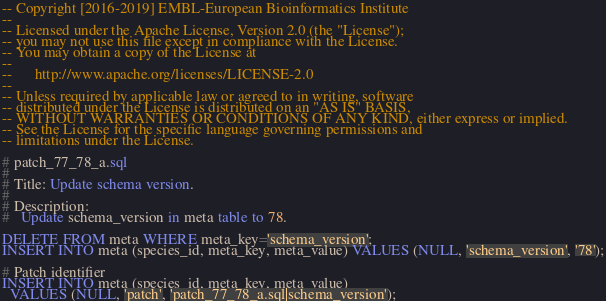Convert code to text. <code><loc_0><loc_0><loc_500><loc_500><_SQL_>-- Copyright [2016-2019] EMBL-European Bioinformatics Institute
-- 
-- Licensed under the Apache License, Version 2.0 (the "License");
-- you may not use this file except in compliance with the License.
-- You may obtain a copy of the License at
-- 
--      http://www.apache.org/licenses/LICENSE-2.0
-- 
-- Unless required by applicable law or agreed to in writing, software
-- distributed under the License is distributed on an "AS IS" BASIS,
-- WITHOUT WARRANTIES OR CONDITIONS OF ANY KIND, either express or implied.
-- See the License for the specific language governing permissions and
-- limitations under the License.

# patch_77_78_a.sql
#
# Title: Update schema version.
#
# Description:
#   Update schema_version in meta table to 78.

DELETE FROM meta WHERE meta_key='schema_version';
INSERT INTO meta (species_id, meta_key, meta_value) VALUES (NULL, 'schema_version', '78');

# Patch identifier
INSERT INTO meta (species_id, meta_key, meta_value)
  VALUES (NULL, 'patch', 'patch_77_78_a.sql|schema_version');
</code> 